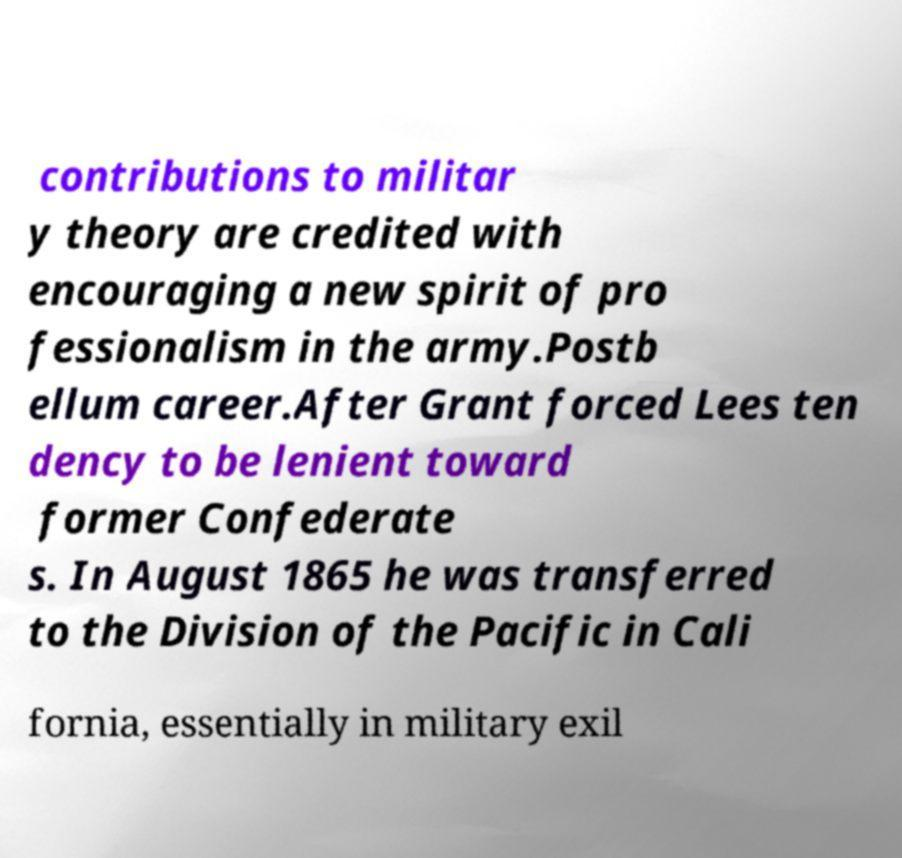Please identify and transcribe the text found in this image. contributions to militar y theory are credited with encouraging a new spirit of pro fessionalism in the army.Postb ellum career.After Grant forced Lees ten dency to be lenient toward former Confederate s. In August 1865 he was transferred to the Division of the Pacific in Cali fornia, essentially in military exil 